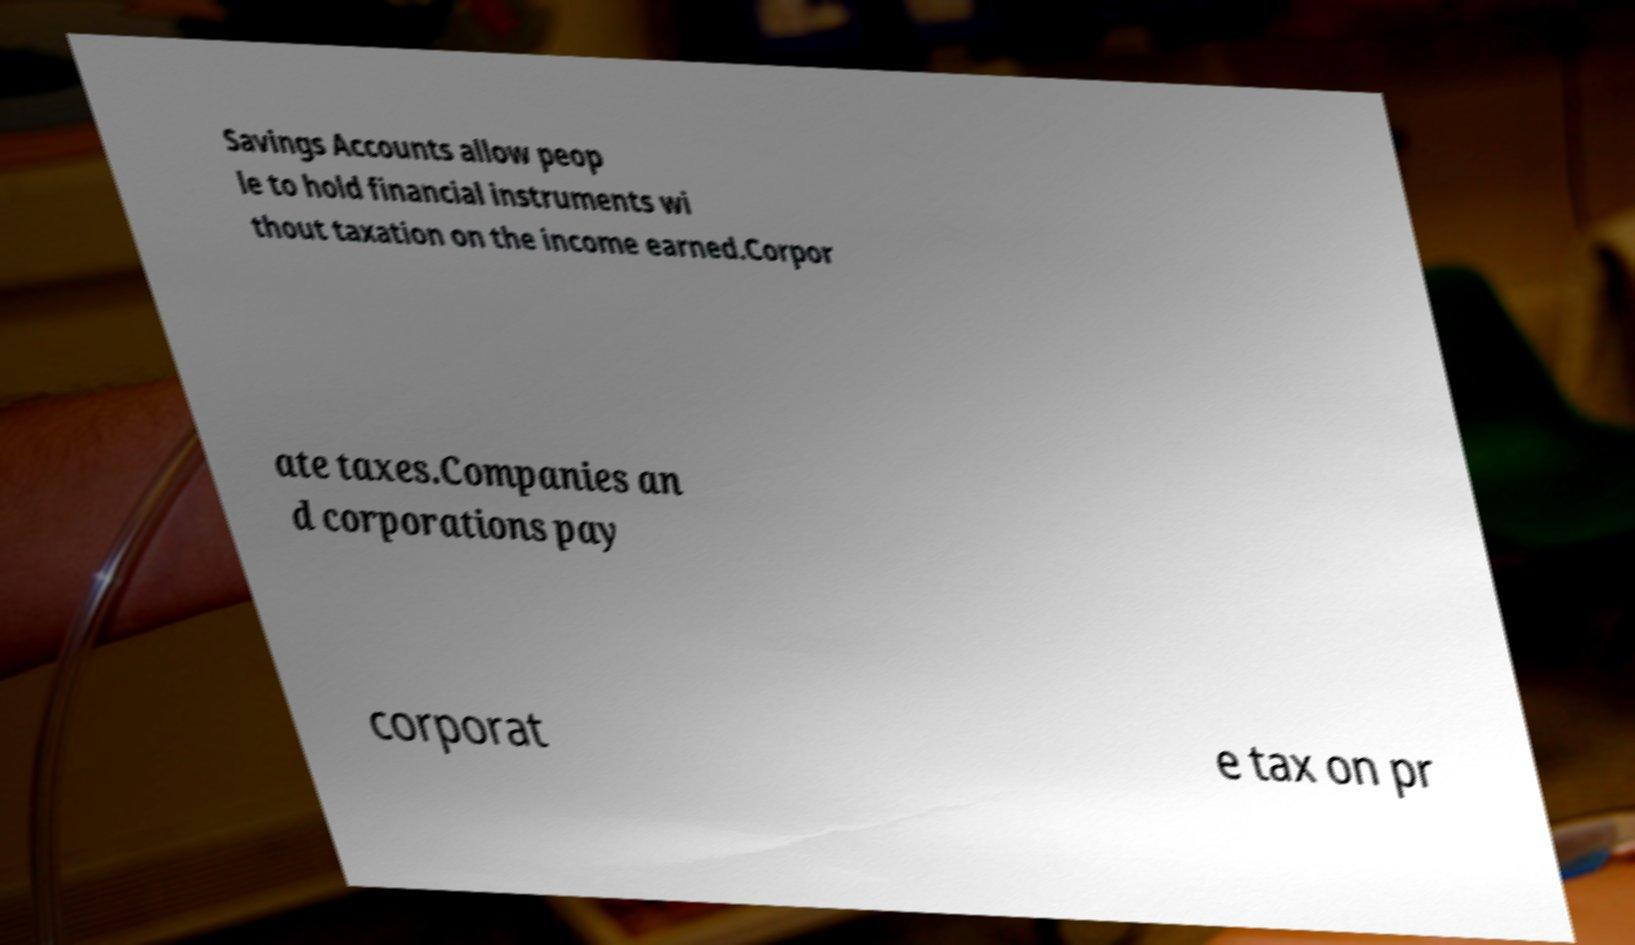What messages or text are displayed in this image? I need them in a readable, typed format. Savings Accounts allow peop le to hold financial instruments wi thout taxation on the income earned.Corpor ate taxes.Companies an d corporations pay corporat e tax on pr 